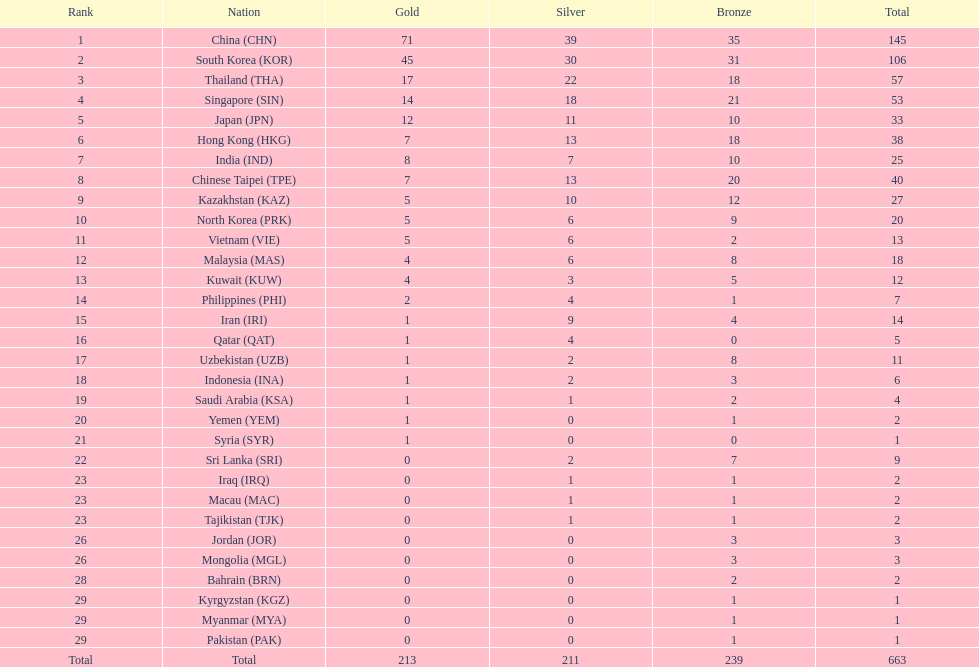Which nations possess an equal quantity of silver medals in the asian youth games as north korea? Vietnam (VIE), Malaysia (MAS). 